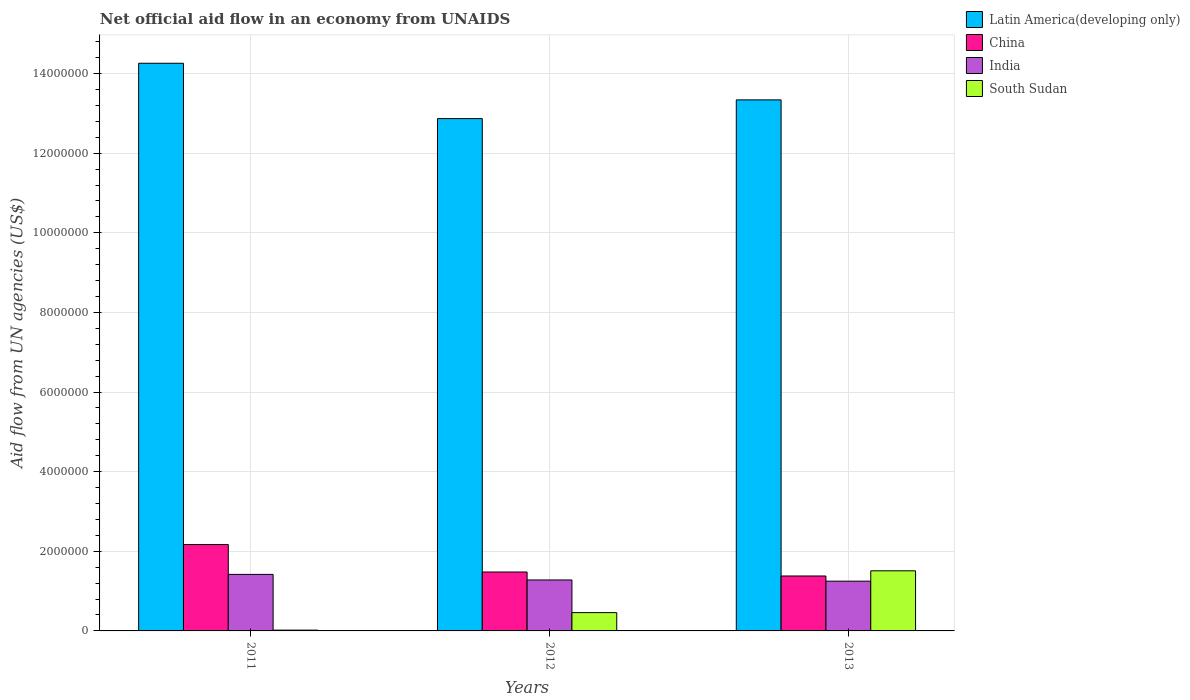How many different coloured bars are there?
Ensure brevity in your answer.  4. How many groups of bars are there?
Offer a very short reply. 3. Are the number of bars per tick equal to the number of legend labels?
Offer a very short reply. Yes. Are the number of bars on each tick of the X-axis equal?
Ensure brevity in your answer.  Yes. How many bars are there on the 1st tick from the right?
Make the answer very short. 4. In how many cases, is the number of bars for a given year not equal to the number of legend labels?
Your answer should be very brief. 0. What is the net official aid flow in Latin America(developing only) in 2013?
Keep it short and to the point. 1.33e+07. Across all years, what is the maximum net official aid flow in South Sudan?
Give a very brief answer. 1.51e+06. Across all years, what is the minimum net official aid flow in South Sudan?
Provide a short and direct response. 2.00e+04. What is the total net official aid flow in India in the graph?
Provide a succinct answer. 3.95e+06. What is the difference between the net official aid flow in India in 2011 and that in 2013?
Your response must be concise. 1.70e+05. What is the difference between the net official aid flow in India in 2011 and the net official aid flow in Latin America(developing only) in 2012?
Provide a succinct answer. -1.14e+07. What is the average net official aid flow in South Sudan per year?
Keep it short and to the point. 6.63e+05. In the year 2012, what is the difference between the net official aid flow in Latin America(developing only) and net official aid flow in China?
Ensure brevity in your answer.  1.14e+07. In how many years, is the net official aid flow in South Sudan greater than 3200000 US$?
Give a very brief answer. 0. What is the ratio of the net official aid flow in South Sudan in 2011 to that in 2012?
Give a very brief answer. 0.04. Is the net official aid flow in China in 2012 less than that in 2013?
Your answer should be compact. No. What is the difference between the highest and the second highest net official aid flow in Latin America(developing only)?
Ensure brevity in your answer.  9.20e+05. What is the difference between the highest and the lowest net official aid flow in India?
Provide a short and direct response. 1.70e+05. In how many years, is the net official aid flow in South Sudan greater than the average net official aid flow in South Sudan taken over all years?
Keep it short and to the point. 1. What does the 4th bar from the left in 2012 represents?
Offer a terse response. South Sudan. How many years are there in the graph?
Provide a succinct answer. 3. Does the graph contain any zero values?
Make the answer very short. No. How many legend labels are there?
Offer a terse response. 4. What is the title of the graph?
Offer a terse response. Net official aid flow in an economy from UNAIDS. What is the label or title of the Y-axis?
Provide a succinct answer. Aid flow from UN agencies (US$). What is the Aid flow from UN agencies (US$) in Latin America(developing only) in 2011?
Provide a short and direct response. 1.43e+07. What is the Aid flow from UN agencies (US$) in China in 2011?
Give a very brief answer. 2.17e+06. What is the Aid flow from UN agencies (US$) of India in 2011?
Make the answer very short. 1.42e+06. What is the Aid flow from UN agencies (US$) of Latin America(developing only) in 2012?
Ensure brevity in your answer.  1.29e+07. What is the Aid flow from UN agencies (US$) of China in 2012?
Provide a succinct answer. 1.48e+06. What is the Aid flow from UN agencies (US$) in India in 2012?
Ensure brevity in your answer.  1.28e+06. What is the Aid flow from UN agencies (US$) of Latin America(developing only) in 2013?
Provide a short and direct response. 1.33e+07. What is the Aid flow from UN agencies (US$) of China in 2013?
Ensure brevity in your answer.  1.38e+06. What is the Aid flow from UN agencies (US$) in India in 2013?
Provide a succinct answer. 1.25e+06. What is the Aid flow from UN agencies (US$) of South Sudan in 2013?
Provide a short and direct response. 1.51e+06. Across all years, what is the maximum Aid flow from UN agencies (US$) in Latin America(developing only)?
Make the answer very short. 1.43e+07. Across all years, what is the maximum Aid flow from UN agencies (US$) of China?
Provide a succinct answer. 2.17e+06. Across all years, what is the maximum Aid flow from UN agencies (US$) in India?
Make the answer very short. 1.42e+06. Across all years, what is the maximum Aid flow from UN agencies (US$) in South Sudan?
Your answer should be compact. 1.51e+06. Across all years, what is the minimum Aid flow from UN agencies (US$) in Latin America(developing only)?
Make the answer very short. 1.29e+07. Across all years, what is the minimum Aid flow from UN agencies (US$) in China?
Ensure brevity in your answer.  1.38e+06. Across all years, what is the minimum Aid flow from UN agencies (US$) in India?
Provide a short and direct response. 1.25e+06. Across all years, what is the minimum Aid flow from UN agencies (US$) in South Sudan?
Keep it short and to the point. 2.00e+04. What is the total Aid flow from UN agencies (US$) in Latin America(developing only) in the graph?
Provide a short and direct response. 4.05e+07. What is the total Aid flow from UN agencies (US$) in China in the graph?
Your answer should be very brief. 5.03e+06. What is the total Aid flow from UN agencies (US$) in India in the graph?
Provide a short and direct response. 3.95e+06. What is the total Aid flow from UN agencies (US$) of South Sudan in the graph?
Ensure brevity in your answer.  1.99e+06. What is the difference between the Aid flow from UN agencies (US$) in Latin America(developing only) in 2011 and that in 2012?
Make the answer very short. 1.39e+06. What is the difference between the Aid flow from UN agencies (US$) in China in 2011 and that in 2012?
Provide a succinct answer. 6.90e+05. What is the difference between the Aid flow from UN agencies (US$) of South Sudan in 2011 and that in 2012?
Make the answer very short. -4.40e+05. What is the difference between the Aid flow from UN agencies (US$) in Latin America(developing only) in 2011 and that in 2013?
Ensure brevity in your answer.  9.20e+05. What is the difference between the Aid flow from UN agencies (US$) in China in 2011 and that in 2013?
Provide a succinct answer. 7.90e+05. What is the difference between the Aid flow from UN agencies (US$) in India in 2011 and that in 2013?
Give a very brief answer. 1.70e+05. What is the difference between the Aid flow from UN agencies (US$) in South Sudan in 2011 and that in 2013?
Your answer should be very brief. -1.49e+06. What is the difference between the Aid flow from UN agencies (US$) of Latin America(developing only) in 2012 and that in 2013?
Provide a succinct answer. -4.70e+05. What is the difference between the Aid flow from UN agencies (US$) in South Sudan in 2012 and that in 2013?
Give a very brief answer. -1.05e+06. What is the difference between the Aid flow from UN agencies (US$) in Latin America(developing only) in 2011 and the Aid flow from UN agencies (US$) in China in 2012?
Give a very brief answer. 1.28e+07. What is the difference between the Aid flow from UN agencies (US$) in Latin America(developing only) in 2011 and the Aid flow from UN agencies (US$) in India in 2012?
Give a very brief answer. 1.30e+07. What is the difference between the Aid flow from UN agencies (US$) in Latin America(developing only) in 2011 and the Aid flow from UN agencies (US$) in South Sudan in 2012?
Keep it short and to the point. 1.38e+07. What is the difference between the Aid flow from UN agencies (US$) of China in 2011 and the Aid flow from UN agencies (US$) of India in 2012?
Provide a succinct answer. 8.90e+05. What is the difference between the Aid flow from UN agencies (US$) in China in 2011 and the Aid flow from UN agencies (US$) in South Sudan in 2012?
Keep it short and to the point. 1.71e+06. What is the difference between the Aid flow from UN agencies (US$) in India in 2011 and the Aid flow from UN agencies (US$) in South Sudan in 2012?
Offer a very short reply. 9.60e+05. What is the difference between the Aid flow from UN agencies (US$) in Latin America(developing only) in 2011 and the Aid flow from UN agencies (US$) in China in 2013?
Offer a very short reply. 1.29e+07. What is the difference between the Aid flow from UN agencies (US$) of Latin America(developing only) in 2011 and the Aid flow from UN agencies (US$) of India in 2013?
Ensure brevity in your answer.  1.30e+07. What is the difference between the Aid flow from UN agencies (US$) of Latin America(developing only) in 2011 and the Aid flow from UN agencies (US$) of South Sudan in 2013?
Provide a succinct answer. 1.28e+07. What is the difference between the Aid flow from UN agencies (US$) in China in 2011 and the Aid flow from UN agencies (US$) in India in 2013?
Provide a short and direct response. 9.20e+05. What is the difference between the Aid flow from UN agencies (US$) in India in 2011 and the Aid flow from UN agencies (US$) in South Sudan in 2013?
Give a very brief answer. -9.00e+04. What is the difference between the Aid flow from UN agencies (US$) in Latin America(developing only) in 2012 and the Aid flow from UN agencies (US$) in China in 2013?
Provide a succinct answer. 1.15e+07. What is the difference between the Aid flow from UN agencies (US$) of Latin America(developing only) in 2012 and the Aid flow from UN agencies (US$) of India in 2013?
Ensure brevity in your answer.  1.16e+07. What is the difference between the Aid flow from UN agencies (US$) of Latin America(developing only) in 2012 and the Aid flow from UN agencies (US$) of South Sudan in 2013?
Provide a short and direct response. 1.14e+07. What is the difference between the Aid flow from UN agencies (US$) in China in 2012 and the Aid flow from UN agencies (US$) in South Sudan in 2013?
Offer a terse response. -3.00e+04. What is the average Aid flow from UN agencies (US$) in Latin America(developing only) per year?
Your answer should be compact. 1.35e+07. What is the average Aid flow from UN agencies (US$) in China per year?
Your answer should be very brief. 1.68e+06. What is the average Aid flow from UN agencies (US$) of India per year?
Give a very brief answer. 1.32e+06. What is the average Aid flow from UN agencies (US$) of South Sudan per year?
Make the answer very short. 6.63e+05. In the year 2011, what is the difference between the Aid flow from UN agencies (US$) of Latin America(developing only) and Aid flow from UN agencies (US$) of China?
Keep it short and to the point. 1.21e+07. In the year 2011, what is the difference between the Aid flow from UN agencies (US$) in Latin America(developing only) and Aid flow from UN agencies (US$) in India?
Ensure brevity in your answer.  1.28e+07. In the year 2011, what is the difference between the Aid flow from UN agencies (US$) in Latin America(developing only) and Aid flow from UN agencies (US$) in South Sudan?
Give a very brief answer. 1.42e+07. In the year 2011, what is the difference between the Aid flow from UN agencies (US$) of China and Aid flow from UN agencies (US$) of India?
Make the answer very short. 7.50e+05. In the year 2011, what is the difference between the Aid flow from UN agencies (US$) in China and Aid flow from UN agencies (US$) in South Sudan?
Your response must be concise. 2.15e+06. In the year 2011, what is the difference between the Aid flow from UN agencies (US$) in India and Aid flow from UN agencies (US$) in South Sudan?
Keep it short and to the point. 1.40e+06. In the year 2012, what is the difference between the Aid flow from UN agencies (US$) in Latin America(developing only) and Aid flow from UN agencies (US$) in China?
Offer a very short reply. 1.14e+07. In the year 2012, what is the difference between the Aid flow from UN agencies (US$) of Latin America(developing only) and Aid flow from UN agencies (US$) of India?
Ensure brevity in your answer.  1.16e+07. In the year 2012, what is the difference between the Aid flow from UN agencies (US$) of Latin America(developing only) and Aid flow from UN agencies (US$) of South Sudan?
Provide a short and direct response. 1.24e+07. In the year 2012, what is the difference between the Aid flow from UN agencies (US$) in China and Aid flow from UN agencies (US$) in South Sudan?
Provide a short and direct response. 1.02e+06. In the year 2012, what is the difference between the Aid flow from UN agencies (US$) in India and Aid flow from UN agencies (US$) in South Sudan?
Offer a terse response. 8.20e+05. In the year 2013, what is the difference between the Aid flow from UN agencies (US$) in Latin America(developing only) and Aid flow from UN agencies (US$) in China?
Offer a very short reply. 1.20e+07. In the year 2013, what is the difference between the Aid flow from UN agencies (US$) of Latin America(developing only) and Aid flow from UN agencies (US$) of India?
Keep it short and to the point. 1.21e+07. In the year 2013, what is the difference between the Aid flow from UN agencies (US$) of Latin America(developing only) and Aid flow from UN agencies (US$) of South Sudan?
Offer a very short reply. 1.18e+07. In the year 2013, what is the difference between the Aid flow from UN agencies (US$) in China and Aid flow from UN agencies (US$) in South Sudan?
Your response must be concise. -1.30e+05. What is the ratio of the Aid flow from UN agencies (US$) of Latin America(developing only) in 2011 to that in 2012?
Your response must be concise. 1.11. What is the ratio of the Aid flow from UN agencies (US$) of China in 2011 to that in 2012?
Make the answer very short. 1.47. What is the ratio of the Aid flow from UN agencies (US$) of India in 2011 to that in 2012?
Offer a very short reply. 1.11. What is the ratio of the Aid flow from UN agencies (US$) of South Sudan in 2011 to that in 2012?
Ensure brevity in your answer.  0.04. What is the ratio of the Aid flow from UN agencies (US$) of Latin America(developing only) in 2011 to that in 2013?
Your answer should be compact. 1.07. What is the ratio of the Aid flow from UN agencies (US$) in China in 2011 to that in 2013?
Offer a very short reply. 1.57. What is the ratio of the Aid flow from UN agencies (US$) of India in 2011 to that in 2013?
Offer a very short reply. 1.14. What is the ratio of the Aid flow from UN agencies (US$) in South Sudan in 2011 to that in 2013?
Give a very brief answer. 0.01. What is the ratio of the Aid flow from UN agencies (US$) in Latin America(developing only) in 2012 to that in 2013?
Your response must be concise. 0.96. What is the ratio of the Aid flow from UN agencies (US$) of China in 2012 to that in 2013?
Make the answer very short. 1.07. What is the ratio of the Aid flow from UN agencies (US$) of South Sudan in 2012 to that in 2013?
Offer a very short reply. 0.3. What is the difference between the highest and the second highest Aid flow from UN agencies (US$) in Latin America(developing only)?
Offer a terse response. 9.20e+05. What is the difference between the highest and the second highest Aid flow from UN agencies (US$) of China?
Provide a succinct answer. 6.90e+05. What is the difference between the highest and the second highest Aid flow from UN agencies (US$) of South Sudan?
Your response must be concise. 1.05e+06. What is the difference between the highest and the lowest Aid flow from UN agencies (US$) of Latin America(developing only)?
Provide a short and direct response. 1.39e+06. What is the difference between the highest and the lowest Aid flow from UN agencies (US$) of China?
Offer a terse response. 7.90e+05. What is the difference between the highest and the lowest Aid flow from UN agencies (US$) of South Sudan?
Ensure brevity in your answer.  1.49e+06. 